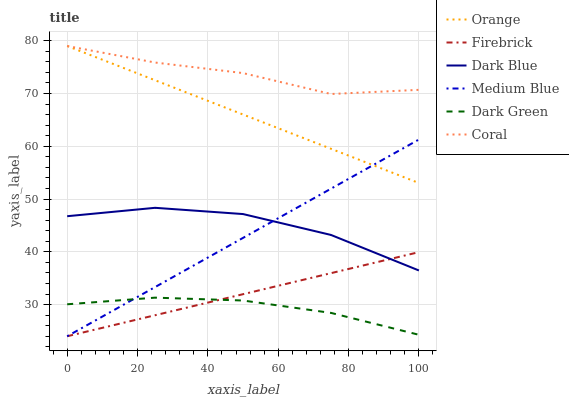Does Dark Green have the minimum area under the curve?
Answer yes or no. Yes. Does Coral have the maximum area under the curve?
Answer yes or no. Yes. Does Medium Blue have the minimum area under the curve?
Answer yes or no. No. Does Medium Blue have the maximum area under the curve?
Answer yes or no. No. Is Firebrick the smoothest?
Answer yes or no. Yes. Is Dark Blue the roughest?
Answer yes or no. Yes. Is Medium Blue the smoothest?
Answer yes or no. No. Is Medium Blue the roughest?
Answer yes or no. No. Does Firebrick have the lowest value?
Answer yes or no. Yes. Does Dark Blue have the lowest value?
Answer yes or no. No. Does Coral have the highest value?
Answer yes or no. Yes. Does Medium Blue have the highest value?
Answer yes or no. No. Is Dark Green less than Dark Blue?
Answer yes or no. Yes. Is Coral greater than Firebrick?
Answer yes or no. Yes. Does Dark Green intersect Medium Blue?
Answer yes or no. Yes. Is Dark Green less than Medium Blue?
Answer yes or no. No. Is Dark Green greater than Medium Blue?
Answer yes or no. No. Does Dark Green intersect Dark Blue?
Answer yes or no. No. 